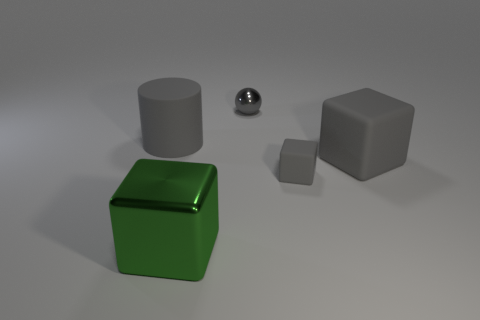Subtract all gray rubber cubes. How many cubes are left? 1 Subtract 2 blocks. How many blocks are left? 1 Add 1 green cubes. How many objects exist? 6 Subtract all spheres. How many objects are left? 4 Subtract all gray blocks. How many blocks are left? 1 Subtract 0 brown cubes. How many objects are left? 5 Subtract all brown cylinders. Subtract all gray blocks. How many cylinders are left? 1 Subtract all cyan blocks. How many green spheres are left? 0 Subtract all big green cylinders. Subtract all metallic cubes. How many objects are left? 4 Add 4 gray rubber cylinders. How many gray rubber cylinders are left? 5 